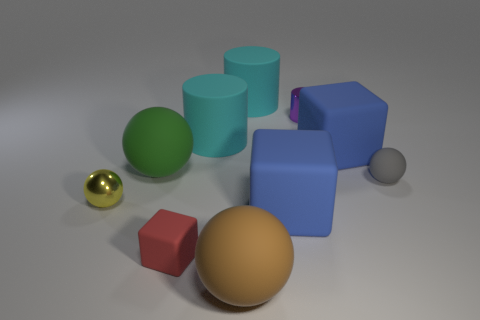Subtract all yellow balls. How many balls are left? 3 Subtract all red cubes. How many cubes are left? 2 Subtract 1 blocks. How many blocks are left? 2 Subtract all spheres. How many objects are left? 6 Subtract all purple cylinders. How many blue blocks are left? 2 Subtract all big brown spheres. Subtract all tiny yellow metal objects. How many objects are left? 8 Add 7 large blue rubber objects. How many large blue rubber objects are left? 9 Add 4 green rubber cubes. How many green rubber cubes exist? 4 Subtract 0 green cylinders. How many objects are left? 10 Subtract all cyan blocks. Subtract all red balls. How many blocks are left? 3 